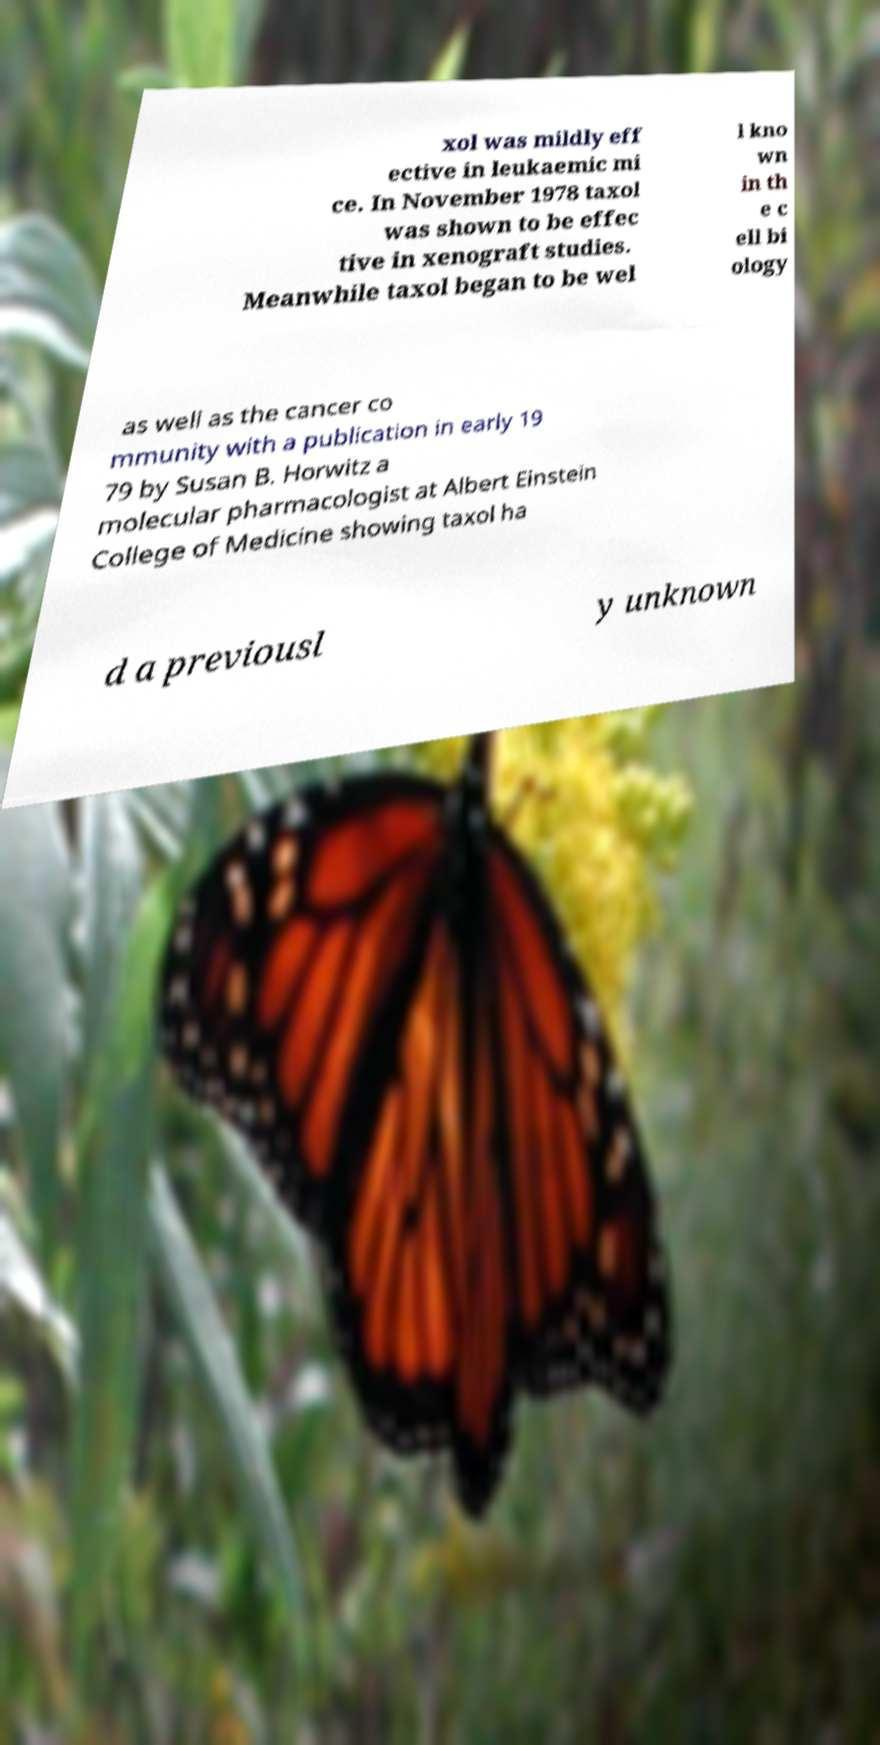Can you accurately transcribe the text from the provided image for me? xol was mildly eff ective in leukaemic mi ce. In November 1978 taxol was shown to be effec tive in xenograft studies. Meanwhile taxol began to be wel l kno wn in th e c ell bi ology as well as the cancer co mmunity with a publication in early 19 79 by Susan B. Horwitz a molecular pharmacologist at Albert Einstein College of Medicine showing taxol ha d a previousl y unknown 